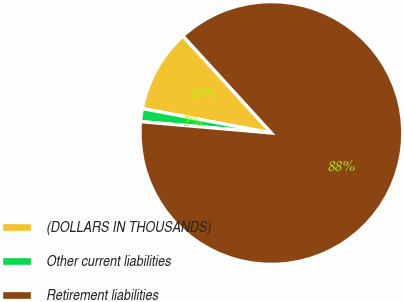<chart> <loc_0><loc_0><loc_500><loc_500><pie_chart><fcel>(DOLLARS IN THOUSANDS)<fcel>Other current liabilities<fcel>Retirement liabilities<nl><fcel>10.25%<fcel>1.6%<fcel>88.14%<nl></chart> 